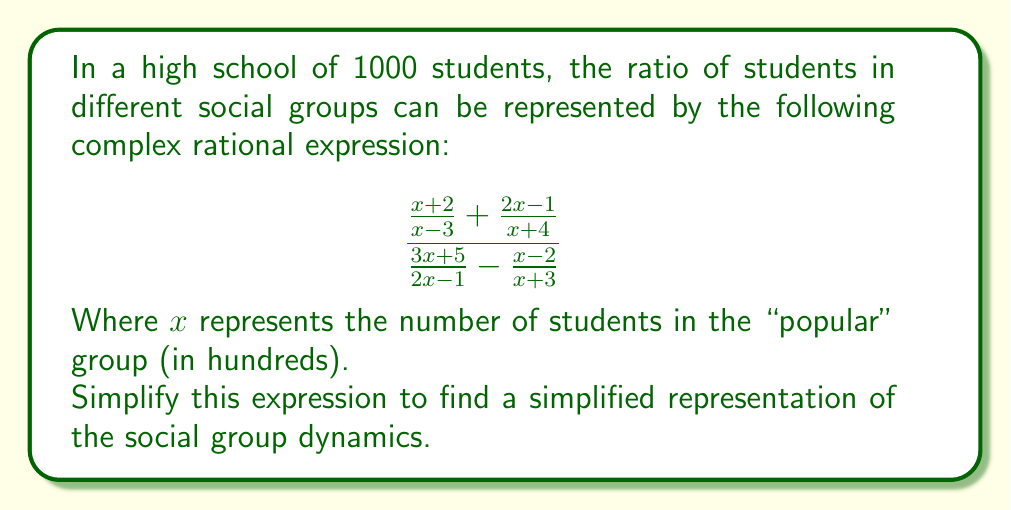Teach me how to tackle this problem. Let's simplify this complex rational expression step-by-step:

1) First, let's find a common denominator for the numerator and denominator separately.

   Numerator: LCD = $(x-3)(x+4)$
   $$\frac{(x+2)(x+4) + (2x-1)(x-3)}{(x-3)(x+4)}$$

   Denominator: LCD = $(2x-1)(x+3)$
   $$\frac{(3x+5)(x+3) - (x-2)(2x-1)}{(2x-1)(x+3)}$$

2) Expand the numerator and denominator:

   Numerator: $(x^2+6x+8) + (2x^2-7x+3) = 3x^2-x+11$
   
   Denominator: $(3x^2+14x+15) - (2x^2-5x+2) = x^2+19x+13$

3) Now our expression looks like this:

   $$\frac{\frac{3x^2-x+11}{(x-3)(x+4)}}{\frac{x^2+19x+13}{(2x-1)(x+3)}}$$

4) To divide fractions, we multiply by the reciprocal:

   $$\frac{3x^2-x+11}{(x-3)(x+4)} \cdot \frac{(2x-1)(x+3)}{x^2+19x+13}$$

5) Cancel common factors if possible (there are none in this case).

6) Multiply the numerators and denominators:

   $$\frac{(3x^2-x+11)(2x-1)(x+3)}{(x-3)(x+4)(x^2+19x+13)}$$

This is the simplified form of the complex rational expression.
Answer: $$\frac{(3x^2-x+11)(2x-1)(x+3)}{(x-3)(x+4)(x^2+19x+13)}$$ 